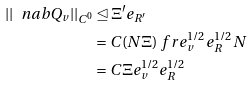<formula> <loc_0><loc_0><loc_500><loc_500>| | \ n a b Q _ { v } | | _ { C ^ { 0 } } & \unlhd \Xi ^ { \prime } e _ { R ^ { \prime } } \\ & = C ( N \Xi ) \ f r { e _ { v } ^ { 1 / 2 } e _ { R } ^ { 1 / 2 } } { N } \\ & = C \Xi e _ { v } ^ { 1 / 2 } e _ { R } ^ { 1 / 2 }</formula> 